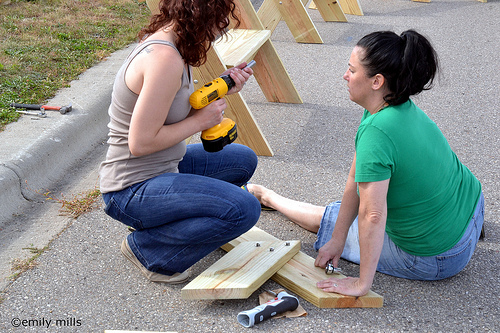<image>
Is the drill on the wood? No. The drill is not positioned on the wood. They may be near each other, but the drill is not supported by or resting on top of the wood. Is the drill above the concrete? Yes. The drill is positioned above the concrete in the vertical space, higher up in the scene. 